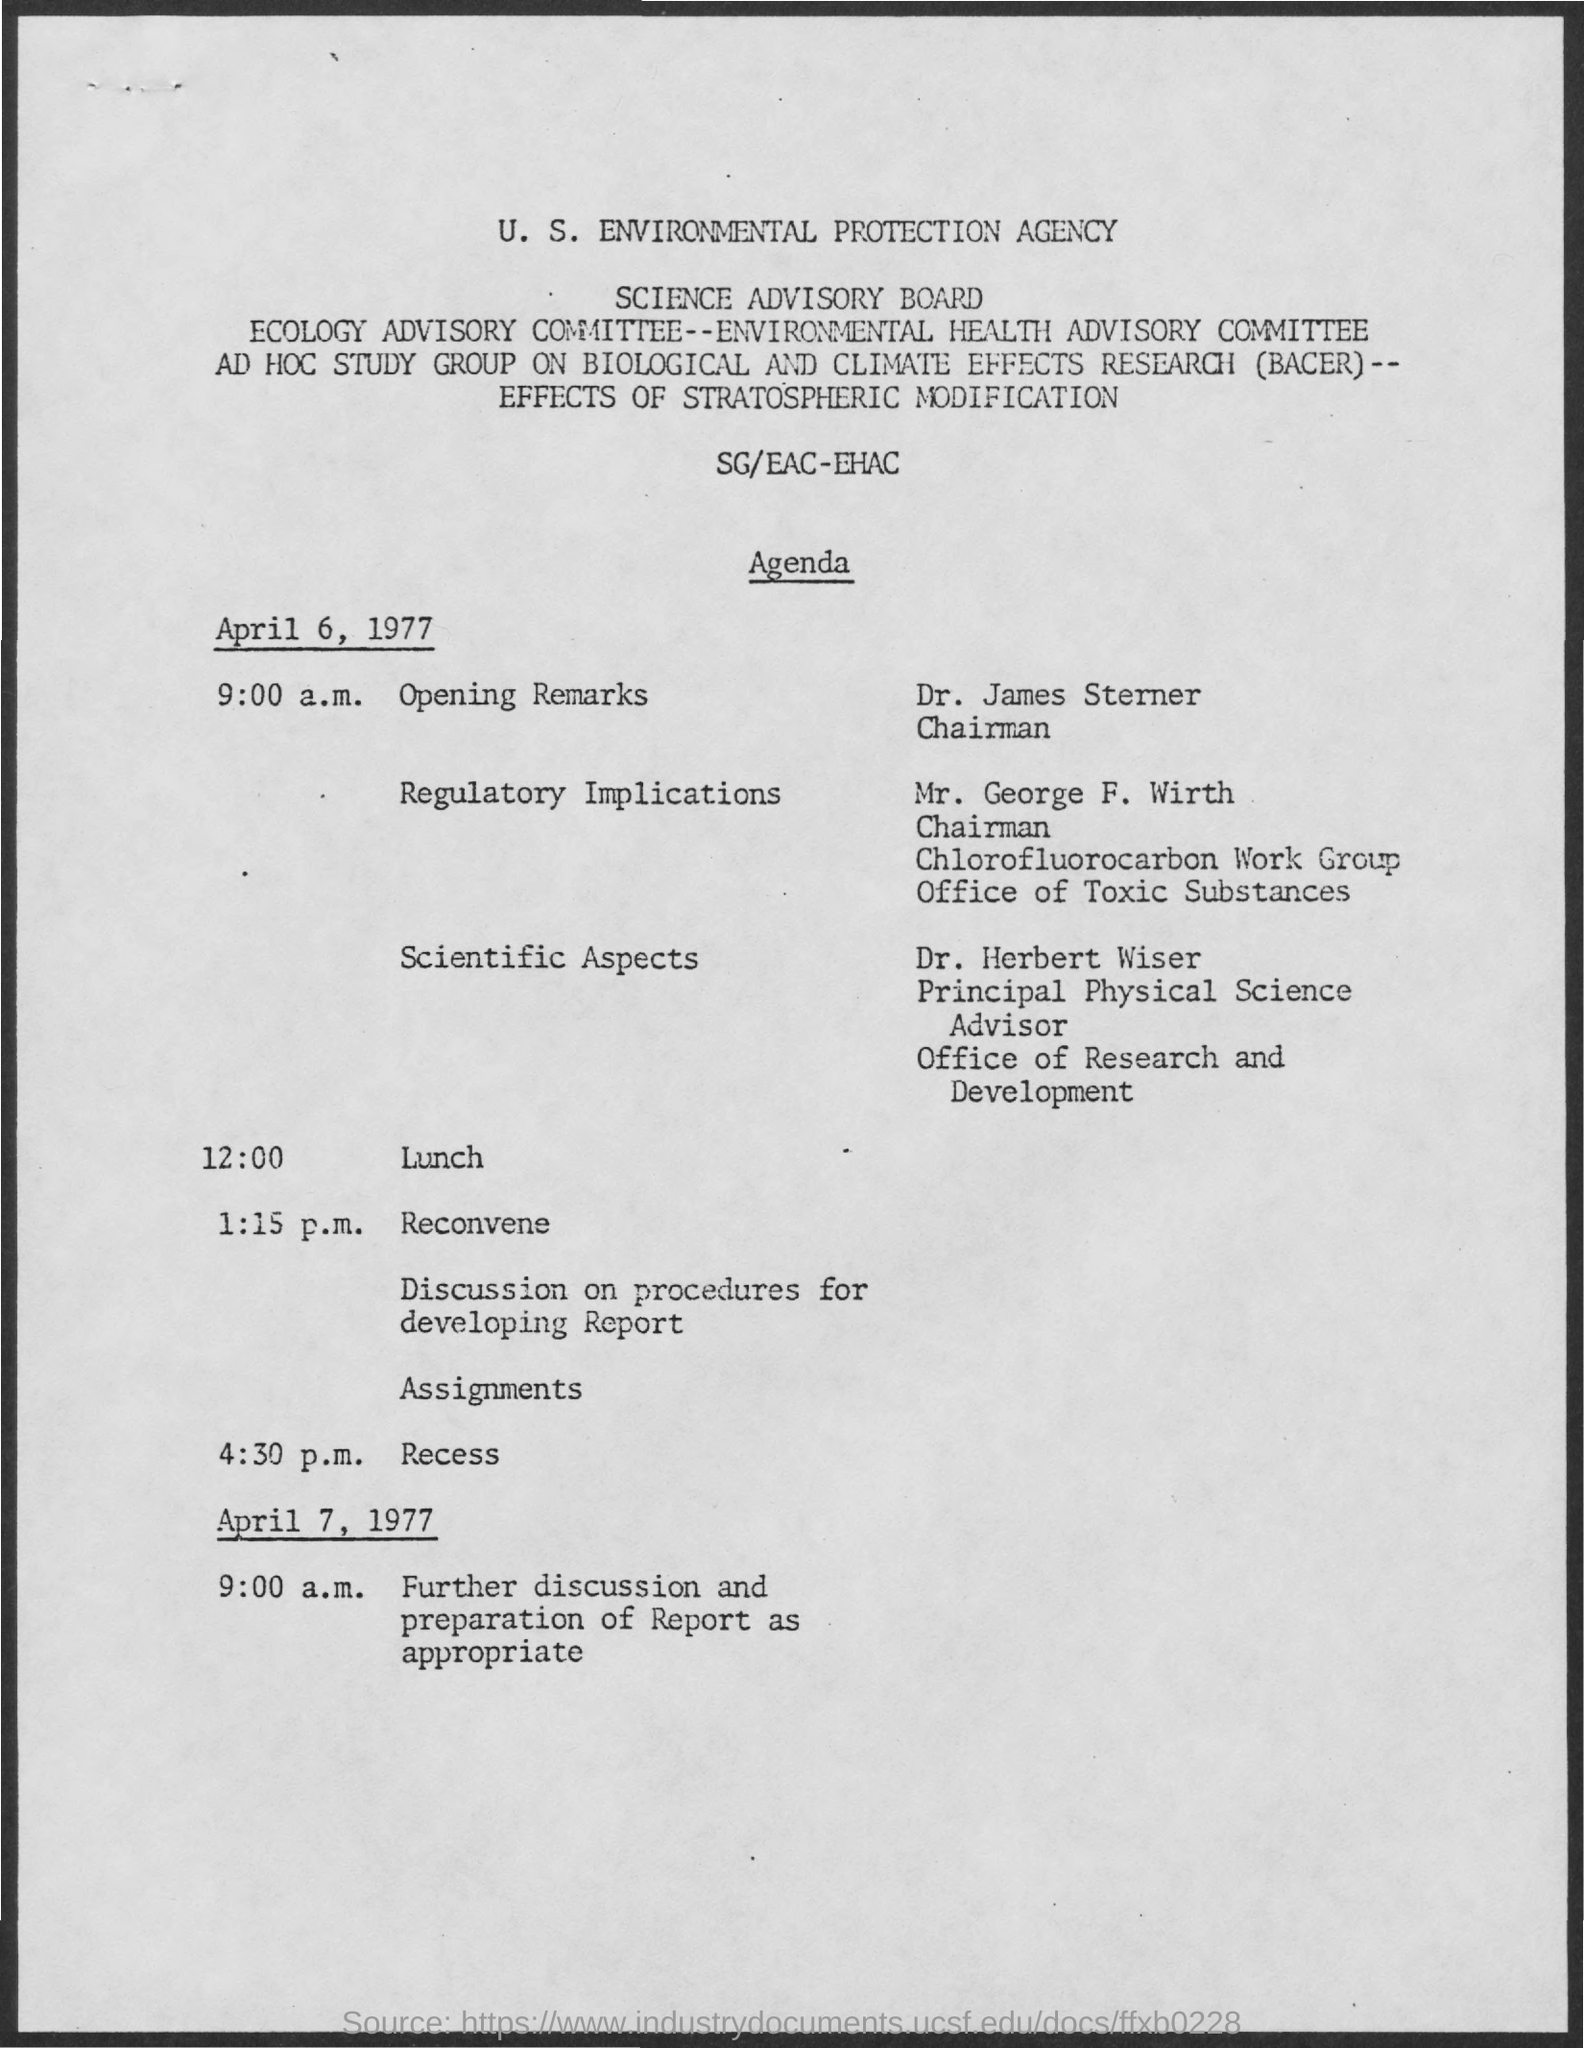What is the name of the board mentioned in the given page ?
Offer a terse response. Science Advisory Board. What is the full form of bacer ?
Make the answer very short. Biological And Climate Effects Research. What is the schedule at the time of 9:00 a.m. on april 6, 1977 ?
Your response must be concise. Opening remarks. What is the schedule at the time of 12:00 ?
Offer a terse response. Lunch. 